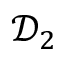<formula> <loc_0><loc_0><loc_500><loc_500>\mathcal { D } _ { 2 }</formula> 